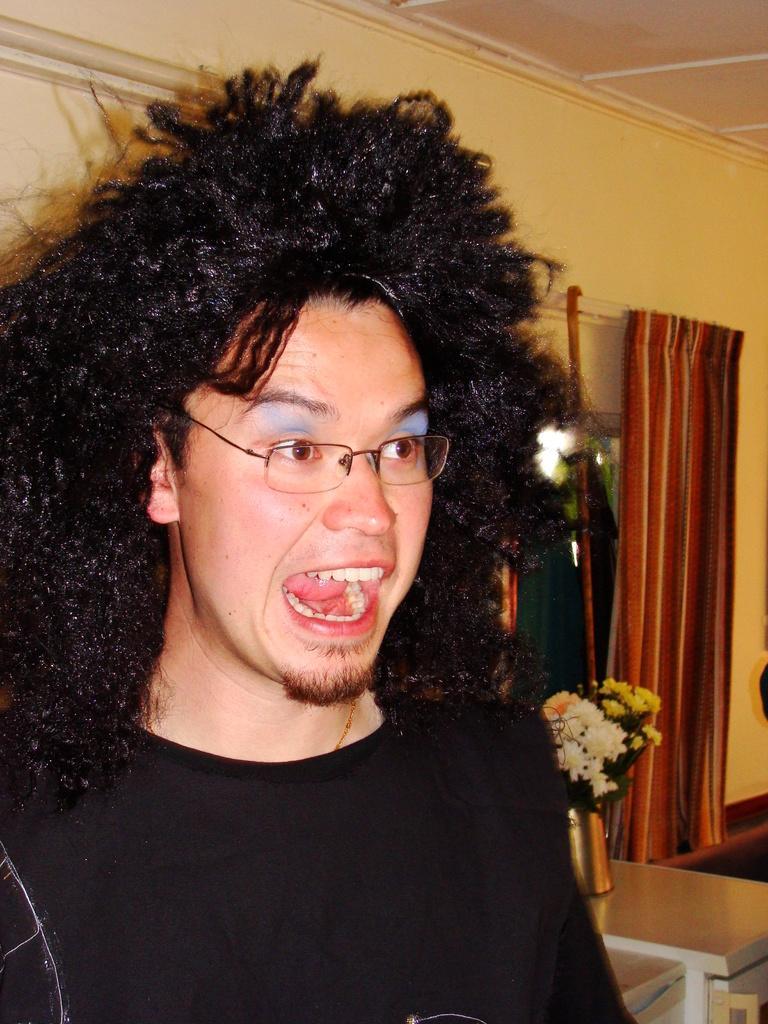Describe this image in one or two sentences. In this image there is a person with a black color shirt and also has curly hair with his mouth open which means he is speaking and he is also wearing spectacles and he also has blue color shade. Beside the person there is curtain which is in multi color and there is also a table with a flower pot on it 